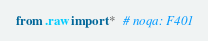<code> <loc_0><loc_0><loc_500><loc_500><_Python_>from .raw import *  # noqa: F401
</code> 